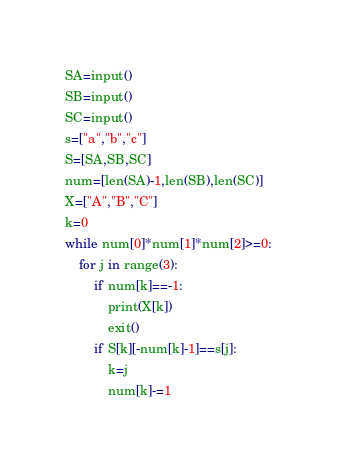<code> <loc_0><loc_0><loc_500><loc_500><_Python_>SA=input()
SB=input()
SC=input()
s=["a","b","c"]
S=[SA,SB,SC]
num=[len(SA)-1,len(SB),len(SC)]
X=["A","B","C"]
k=0
while num[0]*num[1]*num[2]>=0:
    for j in range(3):
        if num[k]==-1:
            print(X[k])
            exit()
        if S[k][-num[k]-1]==s[j]:
            k=j
            num[k]-=1</code> 